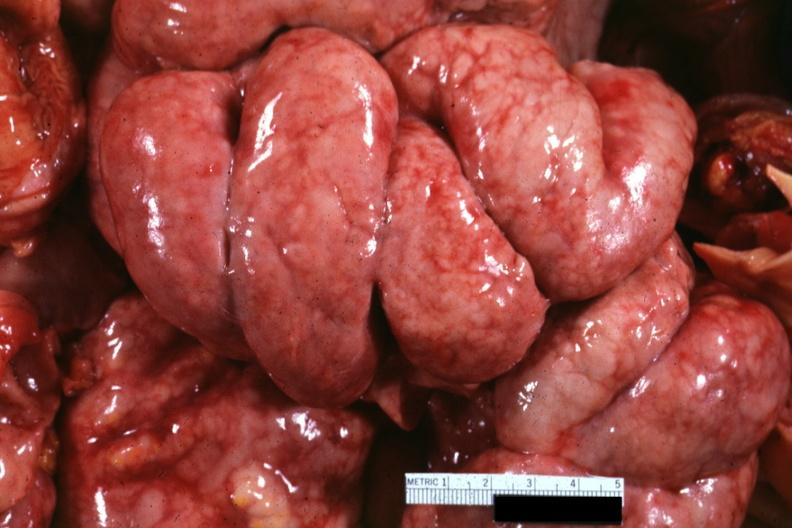does this image show bowel in situ with diffuse thickening of peritoneal surfaces due to metastatic carcinoma breast primary i think?
Answer the question using a single word or phrase. Yes 